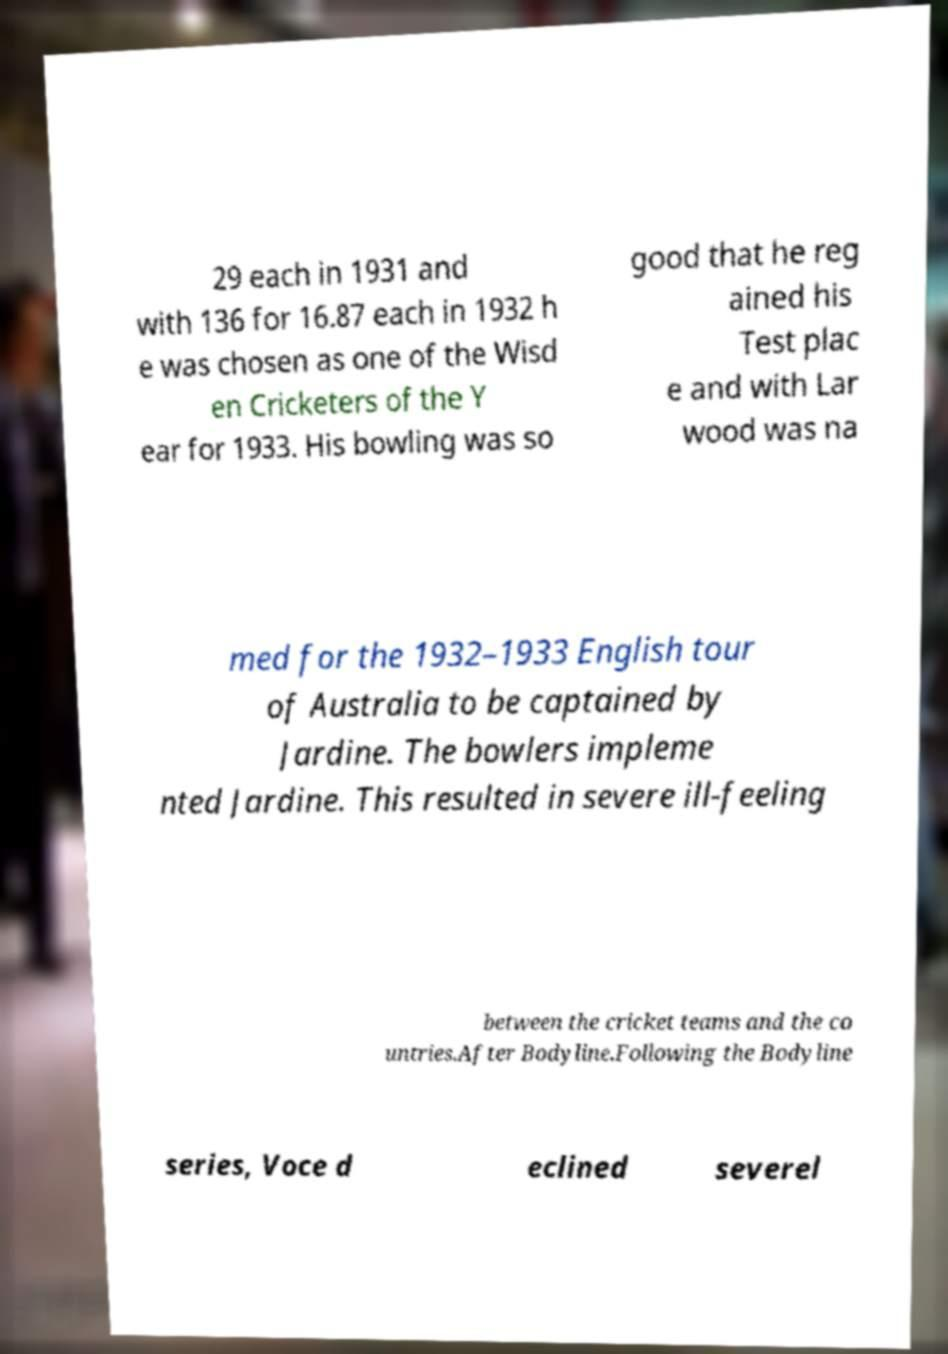I need the written content from this picture converted into text. Can you do that? 29 each in 1931 and with 136 for 16.87 each in 1932 h e was chosen as one of the Wisd en Cricketers of the Y ear for 1933. His bowling was so good that he reg ained his Test plac e and with Lar wood was na med for the 1932–1933 English tour of Australia to be captained by Jardine. The bowlers impleme nted Jardine. This resulted in severe ill-feeling between the cricket teams and the co untries.After Bodyline.Following the Bodyline series, Voce d eclined severel 